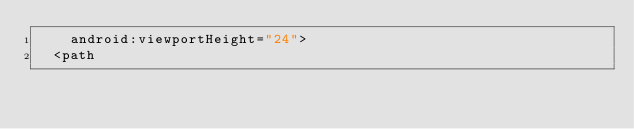Convert code to text. <code><loc_0><loc_0><loc_500><loc_500><_XML_>    android:viewportHeight="24">
  <path</code> 